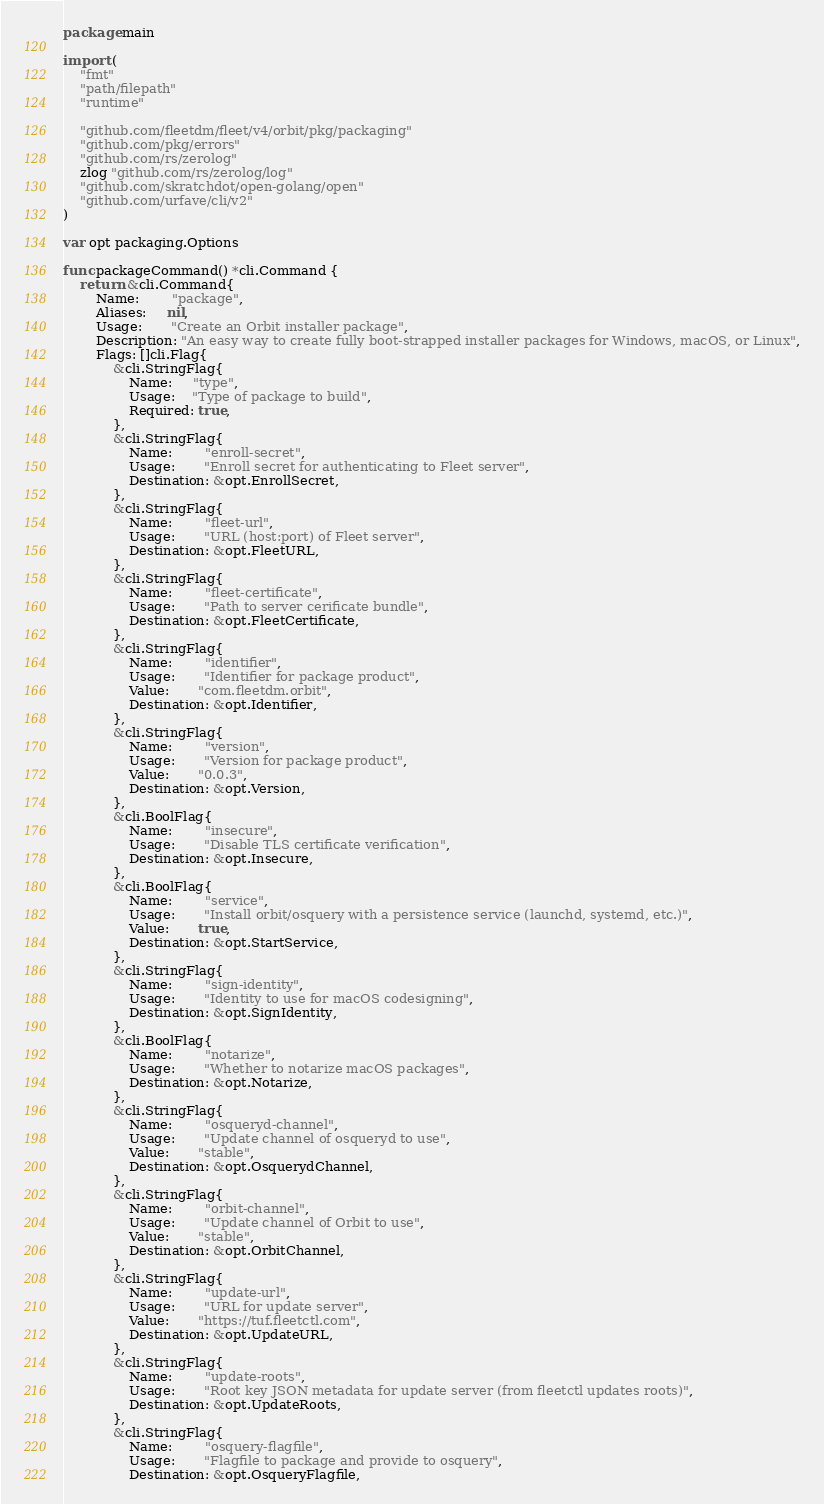Convert code to text. <code><loc_0><loc_0><loc_500><loc_500><_Go_>package main

import (
	"fmt"
	"path/filepath"
	"runtime"

	"github.com/fleetdm/fleet/v4/orbit/pkg/packaging"
	"github.com/pkg/errors"
	"github.com/rs/zerolog"
	zlog "github.com/rs/zerolog/log"
	"github.com/skratchdot/open-golang/open"
	"github.com/urfave/cli/v2"
)

var opt packaging.Options

func packageCommand() *cli.Command {
	return &cli.Command{
		Name:        "package",
		Aliases:     nil,
		Usage:       "Create an Orbit installer package",
		Description: "An easy way to create fully boot-strapped installer packages for Windows, macOS, or Linux",
		Flags: []cli.Flag{
			&cli.StringFlag{
				Name:     "type",
				Usage:    "Type of package to build",
				Required: true,
			},
			&cli.StringFlag{
				Name:        "enroll-secret",
				Usage:       "Enroll secret for authenticating to Fleet server",
				Destination: &opt.EnrollSecret,
			},
			&cli.StringFlag{
				Name:        "fleet-url",
				Usage:       "URL (host:port) of Fleet server",
				Destination: &opt.FleetURL,
			},
			&cli.StringFlag{
				Name:        "fleet-certificate",
				Usage:       "Path to server cerificate bundle",
				Destination: &opt.FleetCertificate,
			},
			&cli.StringFlag{
				Name:        "identifier",
				Usage:       "Identifier for package product",
				Value:       "com.fleetdm.orbit",
				Destination: &opt.Identifier,
			},
			&cli.StringFlag{
				Name:        "version",
				Usage:       "Version for package product",
				Value:       "0.0.3",
				Destination: &opt.Version,
			},
			&cli.BoolFlag{
				Name:        "insecure",
				Usage:       "Disable TLS certificate verification",
				Destination: &opt.Insecure,
			},
			&cli.BoolFlag{
				Name:        "service",
				Usage:       "Install orbit/osquery with a persistence service (launchd, systemd, etc.)",
				Value:       true,
				Destination: &opt.StartService,
			},
			&cli.StringFlag{
				Name:        "sign-identity",
				Usage:       "Identity to use for macOS codesigning",
				Destination: &opt.SignIdentity,
			},
			&cli.BoolFlag{
				Name:        "notarize",
				Usage:       "Whether to notarize macOS packages",
				Destination: &opt.Notarize,
			},
			&cli.StringFlag{
				Name:        "osqueryd-channel",
				Usage:       "Update channel of osqueryd to use",
				Value:       "stable",
				Destination: &opt.OsquerydChannel,
			},
			&cli.StringFlag{
				Name:        "orbit-channel",
				Usage:       "Update channel of Orbit to use",
				Value:       "stable",
				Destination: &opt.OrbitChannel,
			},
			&cli.StringFlag{
				Name:        "update-url",
				Usage:       "URL for update server",
				Value:       "https://tuf.fleetctl.com",
				Destination: &opt.UpdateURL,
			},
			&cli.StringFlag{
				Name:        "update-roots",
				Usage:       "Root key JSON metadata for update server (from fleetctl updates roots)",
				Destination: &opt.UpdateRoots,
			},
			&cli.StringFlag{
				Name:        "osquery-flagfile",
				Usage:       "Flagfile to package and provide to osquery",
				Destination: &opt.OsqueryFlagfile,</code> 